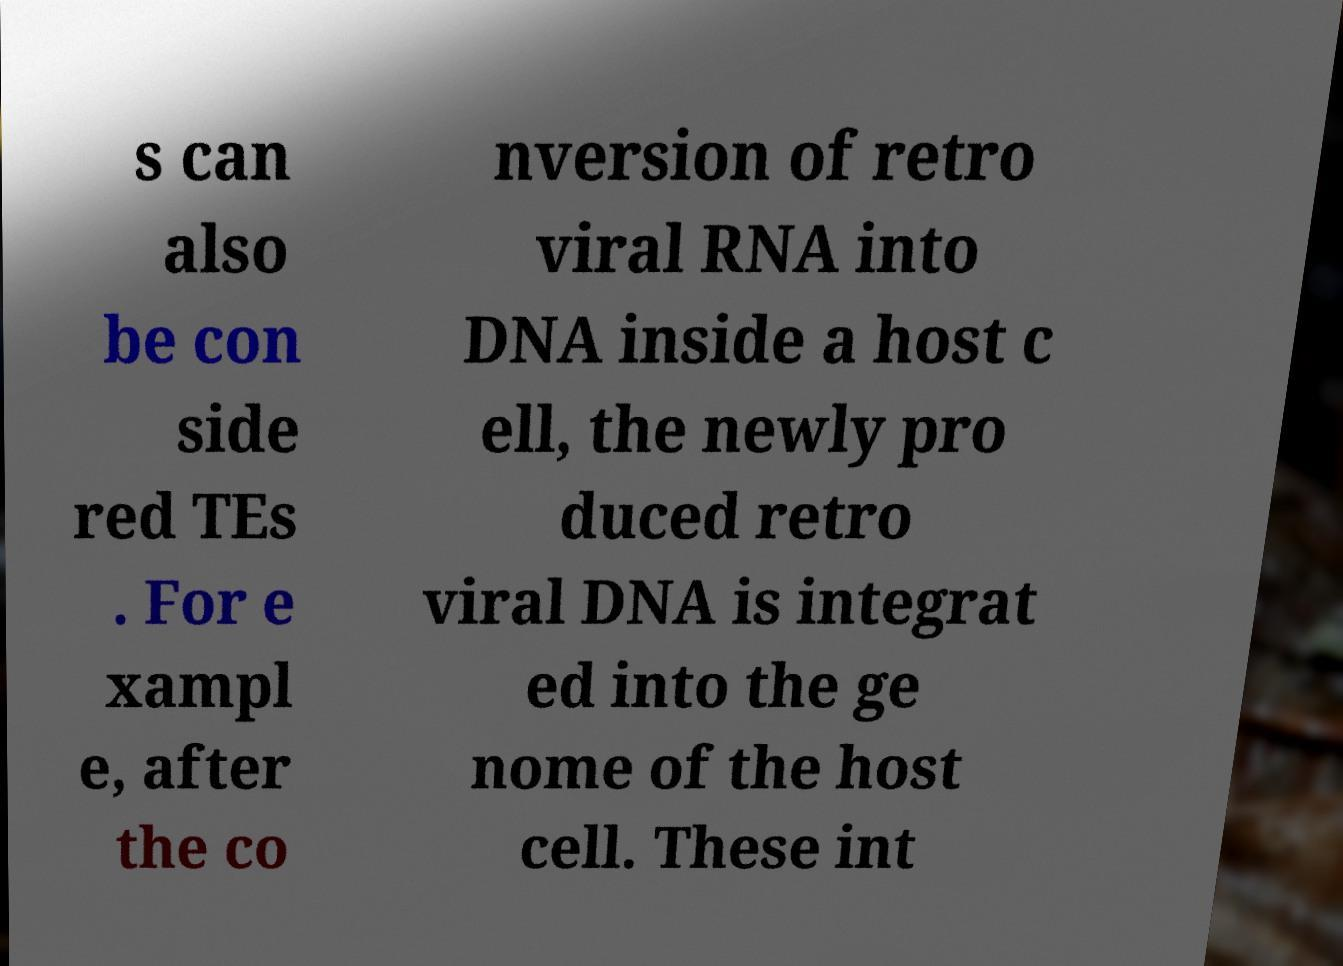Can you read and provide the text displayed in the image?This photo seems to have some interesting text. Can you extract and type it out for me? s can also be con side red TEs . For e xampl e, after the co nversion of retro viral RNA into DNA inside a host c ell, the newly pro duced retro viral DNA is integrat ed into the ge nome of the host cell. These int 